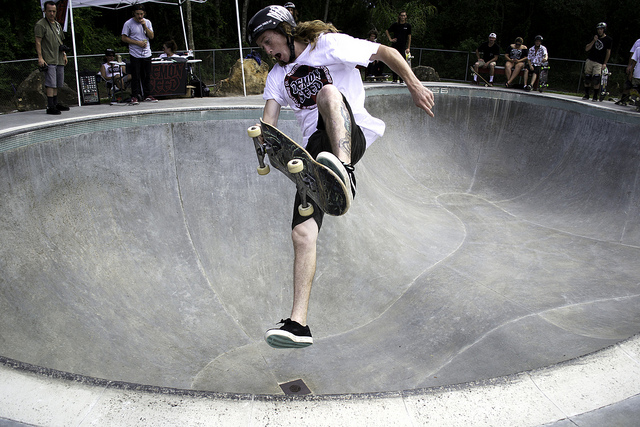Please transcribe the text information in this image. DEMO SEED SB 